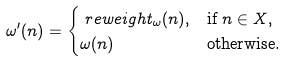Convert formula to latex. <formula><loc_0><loc_0><loc_500><loc_500>& \omega ^ { \prime } ( n ) = \begin{cases} \ r e w e i g h t _ { \omega } ( n ) , & \text {if $n\in X$} , \\ \omega ( n ) & \text {otherwise.} \end{cases}</formula> 